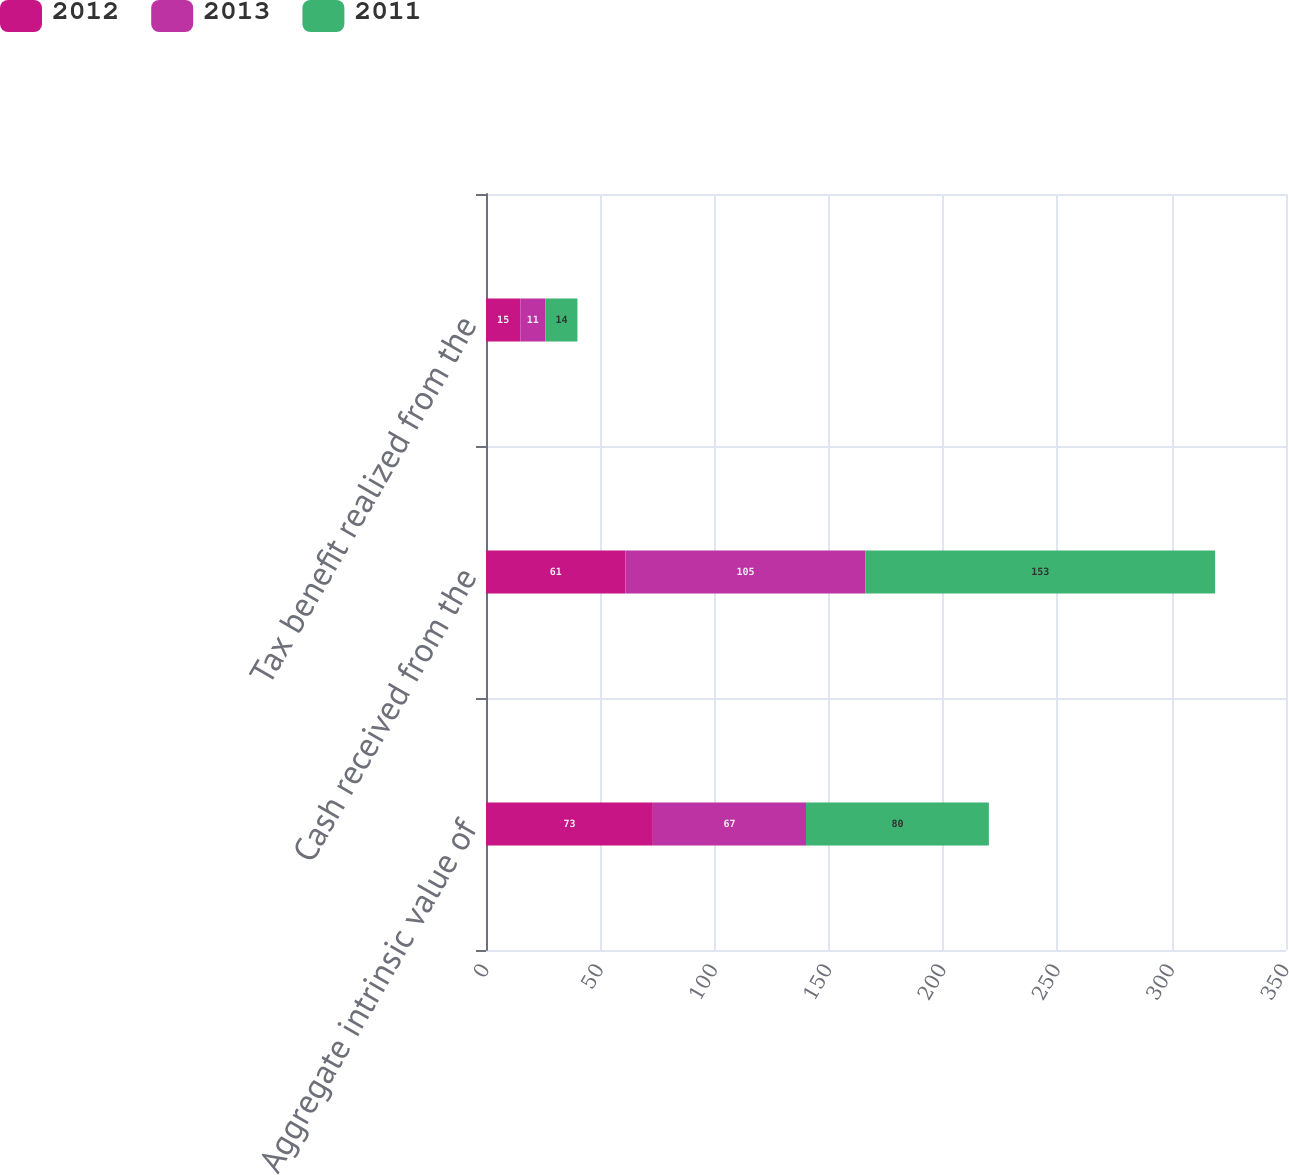Convert chart. <chart><loc_0><loc_0><loc_500><loc_500><stacked_bar_chart><ecel><fcel>Aggregate intrinsic value of<fcel>Cash received from the<fcel>Tax benefit realized from the<nl><fcel>2012<fcel>73<fcel>61<fcel>15<nl><fcel>2013<fcel>67<fcel>105<fcel>11<nl><fcel>2011<fcel>80<fcel>153<fcel>14<nl></chart> 